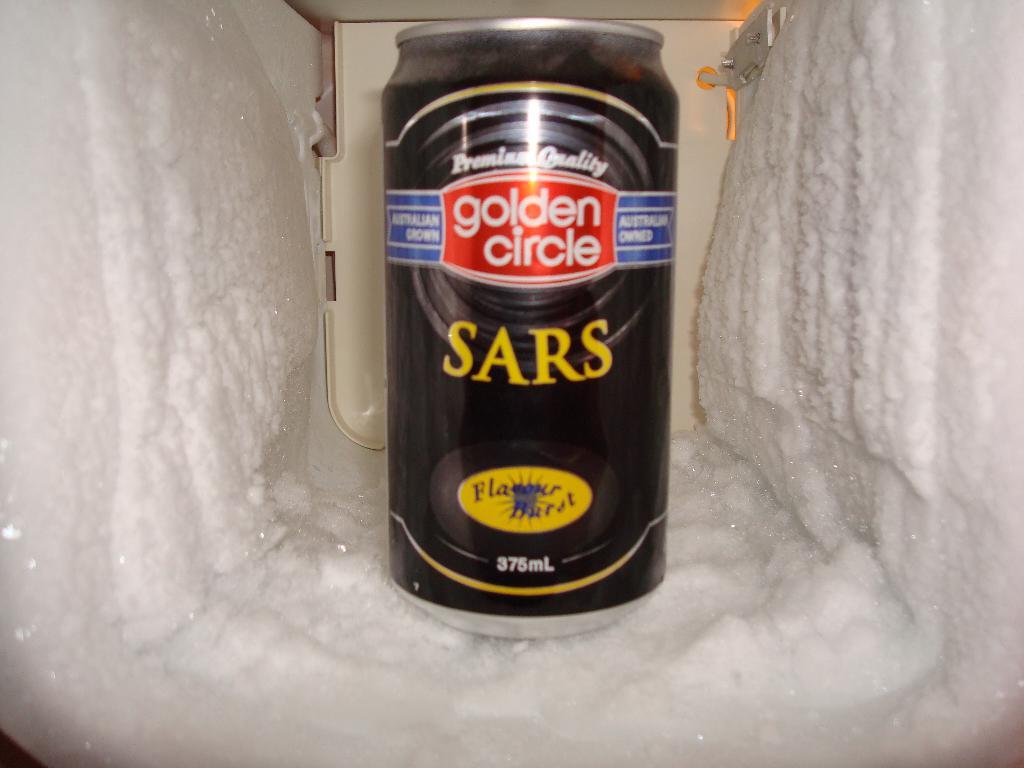What brand of drink is it?
Offer a terse response. Golden circle. How many ml are in this can?
Provide a succinct answer. 375. 